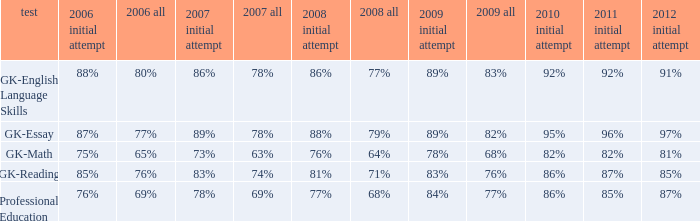What is the percentage for all in 2008 when all in 2007 was 69%? 68%. 